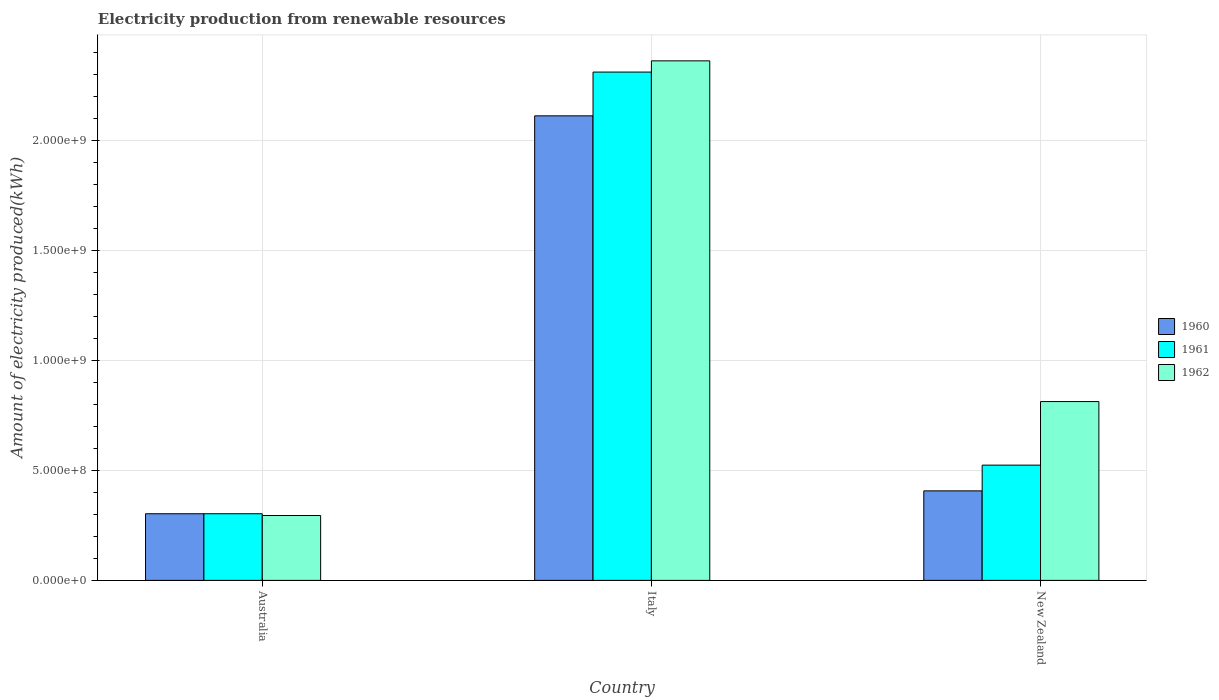How many different coloured bars are there?
Offer a terse response. 3. How many groups of bars are there?
Make the answer very short. 3. Are the number of bars per tick equal to the number of legend labels?
Your response must be concise. Yes. Are the number of bars on each tick of the X-axis equal?
Keep it short and to the point. Yes. How many bars are there on the 1st tick from the left?
Your answer should be compact. 3. What is the label of the 2nd group of bars from the left?
Provide a short and direct response. Italy. In how many cases, is the number of bars for a given country not equal to the number of legend labels?
Offer a terse response. 0. What is the amount of electricity produced in 1961 in Australia?
Ensure brevity in your answer.  3.03e+08. Across all countries, what is the maximum amount of electricity produced in 1961?
Offer a very short reply. 2.31e+09. Across all countries, what is the minimum amount of electricity produced in 1962?
Offer a very short reply. 2.95e+08. What is the total amount of electricity produced in 1960 in the graph?
Offer a terse response. 2.82e+09. What is the difference between the amount of electricity produced in 1960 in Australia and that in New Zealand?
Your answer should be very brief. -1.04e+08. What is the difference between the amount of electricity produced in 1960 in Italy and the amount of electricity produced in 1961 in Australia?
Ensure brevity in your answer.  1.81e+09. What is the average amount of electricity produced in 1961 per country?
Keep it short and to the point. 1.05e+09. What is the difference between the amount of electricity produced of/in 1960 and amount of electricity produced of/in 1962 in New Zealand?
Offer a very short reply. -4.06e+08. In how many countries, is the amount of electricity produced in 1960 greater than 700000000 kWh?
Your response must be concise. 1. What is the ratio of the amount of electricity produced in 1961 in Australia to that in Italy?
Your response must be concise. 0.13. What is the difference between the highest and the second highest amount of electricity produced in 1961?
Give a very brief answer. 1.79e+09. What is the difference between the highest and the lowest amount of electricity produced in 1961?
Make the answer very short. 2.01e+09. Is it the case that in every country, the sum of the amount of electricity produced in 1961 and amount of electricity produced in 1960 is greater than the amount of electricity produced in 1962?
Provide a short and direct response. Yes. How many bars are there?
Provide a short and direct response. 9. Are all the bars in the graph horizontal?
Ensure brevity in your answer.  No. How many countries are there in the graph?
Your response must be concise. 3. How many legend labels are there?
Give a very brief answer. 3. What is the title of the graph?
Offer a terse response. Electricity production from renewable resources. Does "2008" appear as one of the legend labels in the graph?
Provide a succinct answer. No. What is the label or title of the Y-axis?
Offer a very short reply. Amount of electricity produced(kWh). What is the Amount of electricity produced(kWh) of 1960 in Australia?
Your answer should be very brief. 3.03e+08. What is the Amount of electricity produced(kWh) in 1961 in Australia?
Your answer should be very brief. 3.03e+08. What is the Amount of electricity produced(kWh) of 1962 in Australia?
Provide a succinct answer. 2.95e+08. What is the Amount of electricity produced(kWh) in 1960 in Italy?
Offer a very short reply. 2.11e+09. What is the Amount of electricity produced(kWh) of 1961 in Italy?
Provide a succinct answer. 2.31e+09. What is the Amount of electricity produced(kWh) in 1962 in Italy?
Keep it short and to the point. 2.36e+09. What is the Amount of electricity produced(kWh) of 1960 in New Zealand?
Your answer should be very brief. 4.07e+08. What is the Amount of electricity produced(kWh) in 1961 in New Zealand?
Your answer should be very brief. 5.24e+08. What is the Amount of electricity produced(kWh) in 1962 in New Zealand?
Your response must be concise. 8.13e+08. Across all countries, what is the maximum Amount of electricity produced(kWh) in 1960?
Your answer should be compact. 2.11e+09. Across all countries, what is the maximum Amount of electricity produced(kWh) in 1961?
Keep it short and to the point. 2.31e+09. Across all countries, what is the maximum Amount of electricity produced(kWh) in 1962?
Your answer should be compact. 2.36e+09. Across all countries, what is the minimum Amount of electricity produced(kWh) of 1960?
Keep it short and to the point. 3.03e+08. Across all countries, what is the minimum Amount of electricity produced(kWh) in 1961?
Your answer should be compact. 3.03e+08. Across all countries, what is the minimum Amount of electricity produced(kWh) in 1962?
Keep it short and to the point. 2.95e+08. What is the total Amount of electricity produced(kWh) of 1960 in the graph?
Give a very brief answer. 2.82e+09. What is the total Amount of electricity produced(kWh) of 1961 in the graph?
Offer a terse response. 3.14e+09. What is the total Amount of electricity produced(kWh) of 1962 in the graph?
Provide a short and direct response. 3.47e+09. What is the difference between the Amount of electricity produced(kWh) of 1960 in Australia and that in Italy?
Your answer should be very brief. -1.81e+09. What is the difference between the Amount of electricity produced(kWh) in 1961 in Australia and that in Italy?
Make the answer very short. -2.01e+09. What is the difference between the Amount of electricity produced(kWh) of 1962 in Australia and that in Italy?
Make the answer very short. -2.07e+09. What is the difference between the Amount of electricity produced(kWh) of 1960 in Australia and that in New Zealand?
Ensure brevity in your answer.  -1.04e+08. What is the difference between the Amount of electricity produced(kWh) in 1961 in Australia and that in New Zealand?
Keep it short and to the point. -2.21e+08. What is the difference between the Amount of electricity produced(kWh) of 1962 in Australia and that in New Zealand?
Your answer should be very brief. -5.18e+08. What is the difference between the Amount of electricity produced(kWh) of 1960 in Italy and that in New Zealand?
Provide a short and direct response. 1.70e+09. What is the difference between the Amount of electricity produced(kWh) in 1961 in Italy and that in New Zealand?
Offer a terse response. 1.79e+09. What is the difference between the Amount of electricity produced(kWh) in 1962 in Italy and that in New Zealand?
Your response must be concise. 1.55e+09. What is the difference between the Amount of electricity produced(kWh) in 1960 in Australia and the Amount of electricity produced(kWh) in 1961 in Italy?
Offer a terse response. -2.01e+09. What is the difference between the Amount of electricity produced(kWh) of 1960 in Australia and the Amount of electricity produced(kWh) of 1962 in Italy?
Offer a very short reply. -2.06e+09. What is the difference between the Amount of electricity produced(kWh) in 1961 in Australia and the Amount of electricity produced(kWh) in 1962 in Italy?
Keep it short and to the point. -2.06e+09. What is the difference between the Amount of electricity produced(kWh) in 1960 in Australia and the Amount of electricity produced(kWh) in 1961 in New Zealand?
Provide a short and direct response. -2.21e+08. What is the difference between the Amount of electricity produced(kWh) in 1960 in Australia and the Amount of electricity produced(kWh) in 1962 in New Zealand?
Provide a succinct answer. -5.10e+08. What is the difference between the Amount of electricity produced(kWh) in 1961 in Australia and the Amount of electricity produced(kWh) in 1962 in New Zealand?
Give a very brief answer. -5.10e+08. What is the difference between the Amount of electricity produced(kWh) in 1960 in Italy and the Amount of electricity produced(kWh) in 1961 in New Zealand?
Offer a very short reply. 1.59e+09. What is the difference between the Amount of electricity produced(kWh) of 1960 in Italy and the Amount of electricity produced(kWh) of 1962 in New Zealand?
Your response must be concise. 1.30e+09. What is the difference between the Amount of electricity produced(kWh) of 1961 in Italy and the Amount of electricity produced(kWh) of 1962 in New Zealand?
Your answer should be very brief. 1.50e+09. What is the average Amount of electricity produced(kWh) of 1960 per country?
Make the answer very short. 9.41e+08. What is the average Amount of electricity produced(kWh) in 1961 per country?
Offer a terse response. 1.05e+09. What is the average Amount of electricity produced(kWh) of 1962 per country?
Keep it short and to the point. 1.16e+09. What is the difference between the Amount of electricity produced(kWh) in 1960 and Amount of electricity produced(kWh) in 1961 in Australia?
Offer a terse response. 0. What is the difference between the Amount of electricity produced(kWh) of 1960 and Amount of electricity produced(kWh) of 1962 in Australia?
Offer a terse response. 8.00e+06. What is the difference between the Amount of electricity produced(kWh) in 1961 and Amount of electricity produced(kWh) in 1962 in Australia?
Keep it short and to the point. 8.00e+06. What is the difference between the Amount of electricity produced(kWh) of 1960 and Amount of electricity produced(kWh) of 1961 in Italy?
Keep it short and to the point. -1.99e+08. What is the difference between the Amount of electricity produced(kWh) of 1960 and Amount of electricity produced(kWh) of 1962 in Italy?
Your response must be concise. -2.50e+08. What is the difference between the Amount of electricity produced(kWh) of 1961 and Amount of electricity produced(kWh) of 1962 in Italy?
Give a very brief answer. -5.10e+07. What is the difference between the Amount of electricity produced(kWh) of 1960 and Amount of electricity produced(kWh) of 1961 in New Zealand?
Ensure brevity in your answer.  -1.17e+08. What is the difference between the Amount of electricity produced(kWh) of 1960 and Amount of electricity produced(kWh) of 1962 in New Zealand?
Offer a terse response. -4.06e+08. What is the difference between the Amount of electricity produced(kWh) of 1961 and Amount of electricity produced(kWh) of 1962 in New Zealand?
Provide a succinct answer. -2.89e+08. What is the ratio of the Amount of electricity produced(kWh) in 1960 in Australia to that in Italy?
Offer a very short reply. 0.14. What is the ratio of the Amount of electricity produced(kWh) in 1961 in Australia to that in Italy?
Provide a short and direct response. 0.13. What is the ratio of the Amount of electricity produced(kWh) in 1962 in Australia to that in Italy?
Your answer should be compact. 0.12. What is the ratio of the Amount of electricity produced(kWh) of 1960 in Australia to that in New Zealand?
Keep it short and to the point. 0.74. What is the ratio of the Amount of electricity produced(kWh) of 1961 in Australia to that in New Zealand?
Provide a short and direct response. 0.58. What is the ratio of the Amount of electricity produced(kWh) in 1962 in Australia to that in New Zealand?
Ensure brevity in your answer.  0.36. What is the ratio of the Amount of electricity produced(kWh) in 1960 in Italy to that in New Zealand?
Give a very brief answer. 5.19. What is the ratio of the Amount of electricity produced(kWh) of 1961 in Italy to that in New Zealand?
Your response must be concise. 4.41. What is the ratio of the Amount of electricity produced(kWh) in 1962 in Italy to that in New Zealand?
Ensure brevity in your answer.  2.91. What is the difference between the highest and the second highest Amount of electricity produced(kWh) in 1960?
Offer a terse response. 1.70e+09. What is the difference between the highest and the second highest Amount of electricity produced(kWh) of 1961?
Keep it short and to the point. 1.79e+09. What is the difference between the highest and the second highest Amount of electricity produced(kWh) of 1962?
Your response must be concise. 1.55e+09. What is the difference between the highest and the lowest Amount of electricity produced(kWh) of 1960?
Your answer should be compact. 1.81e+09. What is the difference between the highest and the lowest Amount of electricity produced(kWh) of 1961?
Provide a succinct answer. 2.01e+09. What is the difference between the highest and the lowest Amount of electricity produced(kWh) in 1962?
Provide a short and direct response. 2.07e+09. 